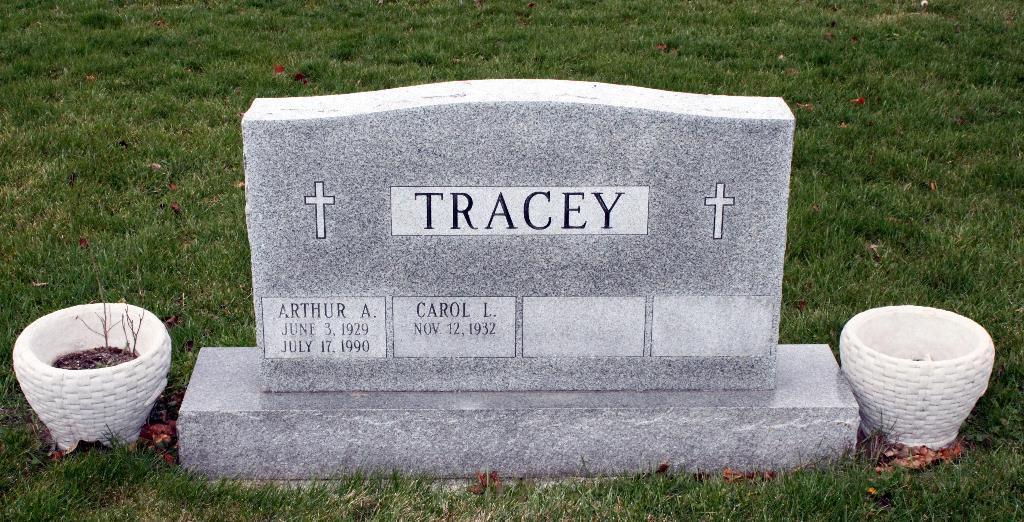What is the main subject of the image? There is a grave in the image. Where is the grave located? The grave is on the grass. Are there any additional objects near the grave? Yes, there are flower pots beside the grave. What type of sound can be heard coming from the grave in the image? There is no sound coming from the grave in the image. What hour of the day is depicted in the image? The image does not provide information about the time of day. 